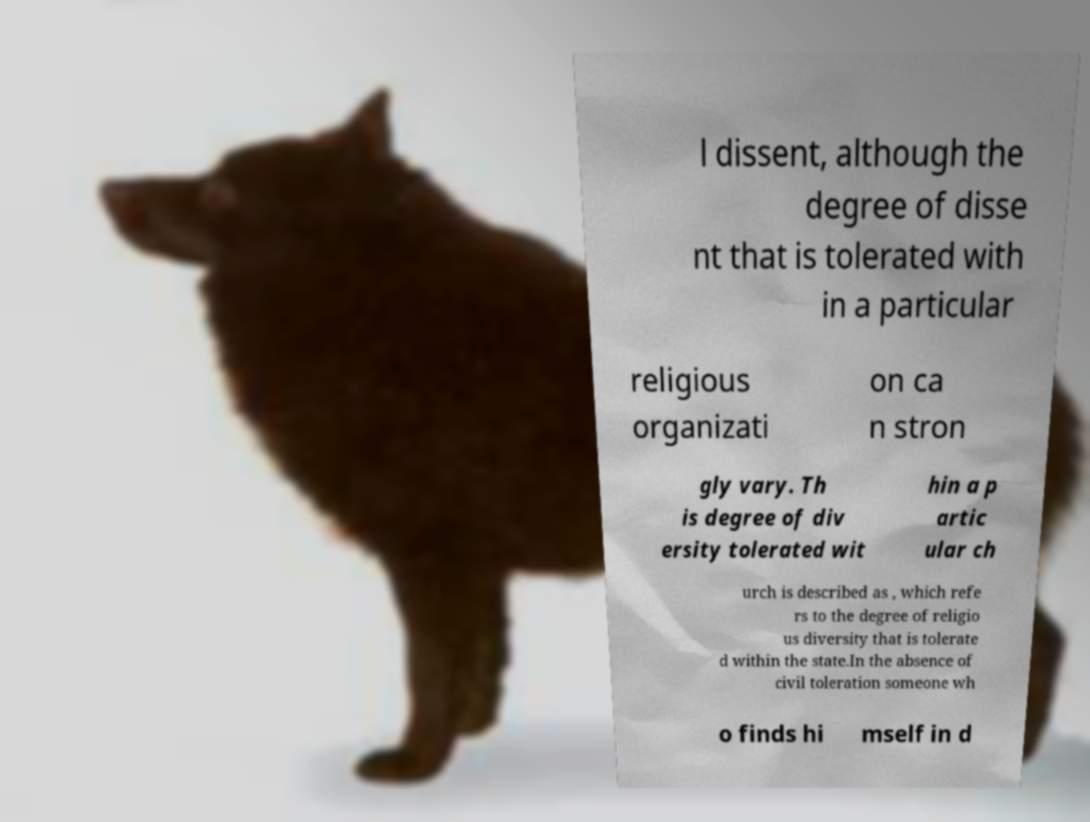For documentation purposes, I need the text within this image transcribed. Could you provide that? l dissent, although the degree of disse nt that is tolerated with in a particular religious organizati on ca n stron gly vary. Th is degree of div ersity tolerated wit hin a p artic ular ch urch is described as , which refe rs to the degree of religio us diversity that is tolerate d within the state.In the absence of civil toleration someone wh o finds hi mself in d 